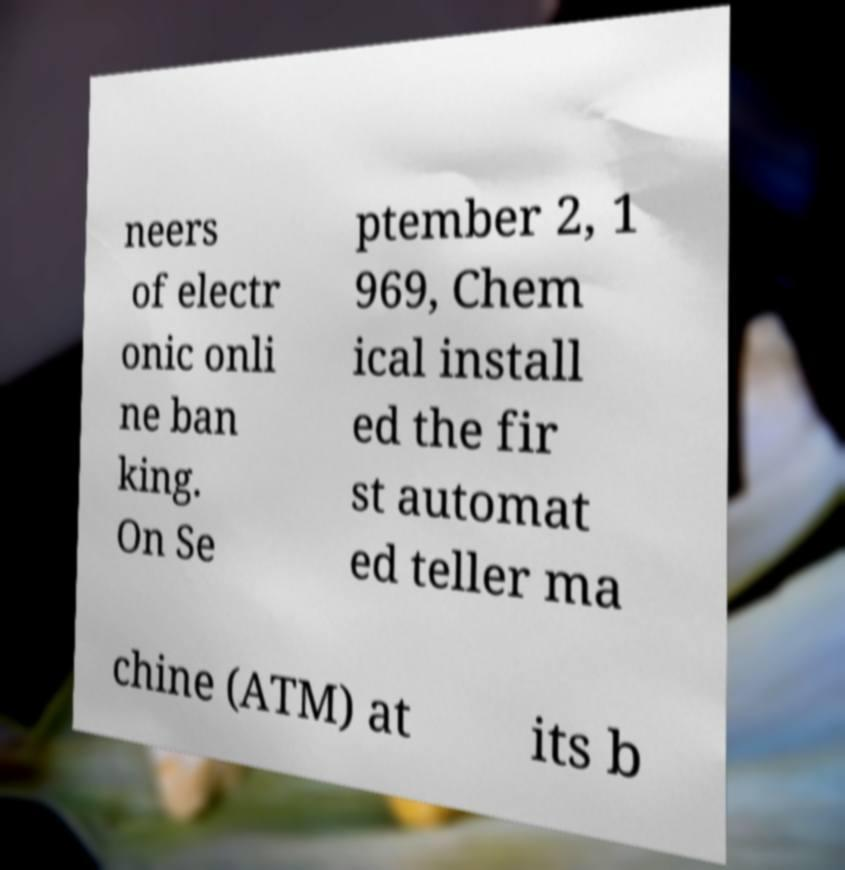Could you extract and type out the text from this image? neers of electr onic onli ne ban king. On Se ptember 2, 1 969, Chem ical install ed the fir st automat ed teller ma chine (ATM) at its b 